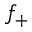<formula> <loc_0><loc_0><loc_500><loc_500>f _ { + }</formula> 